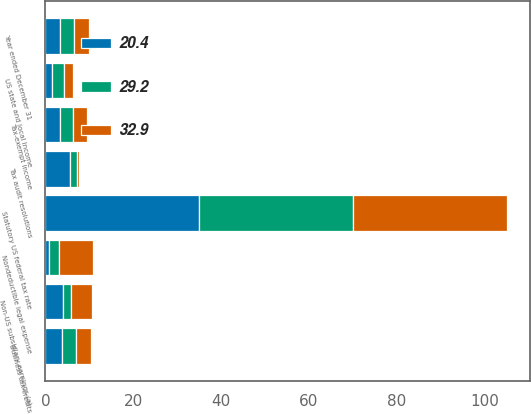Convert chart. <chart><loc_0><loc_0><loc_500><loc_500><stacked_bar_chart><ecel><fcel>Year ended December 31<fcel>Statutory US federal tax rate<fcel>US state and local income<fcel>Tax-exempt income<fcel>Non-US subsidiary earnings (a)<fcel>Business tax credits<fcel>Nondeductible legal expense<fcel>Tax audit resolutions<nl><fcel>20.4<fcel>3.3<fcel>35<fcel>1.5<fcel>3.3<fcel>3.9<fcel>3.7<fcel>0.8<fcel>5.7<nl><fcel>29.2<fcel>3.3<fcel>35<fcel>2.7<fcel>3.1<fcel>2<fcel>3.3<fcel>2.3<fcel>1.4<nl><fcel>32.9<fcel>3.3<fcel>35<fcel>2.2<fcel>3<fcel>4.8<fcel>3.4<fcel>7.8<fcel>0.6<nl></chart> 